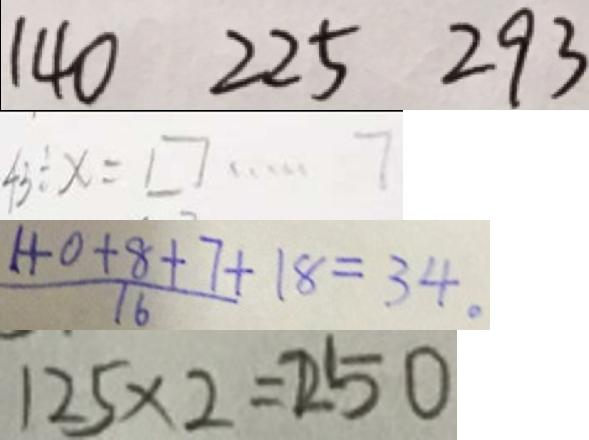Convert formula to latex. <formula><loc_0><loc_0><loc_500><loc_500>1 4 0 2 2 5 2 9 3 
 4 3 \div x = \square \cdots 7 
 \frac { 1 + 0 + 8 + 7 } { 1 6 } + 1 8 = 3 4 . 
 1 2 5 \times 2 = 2 5 0</formula> 